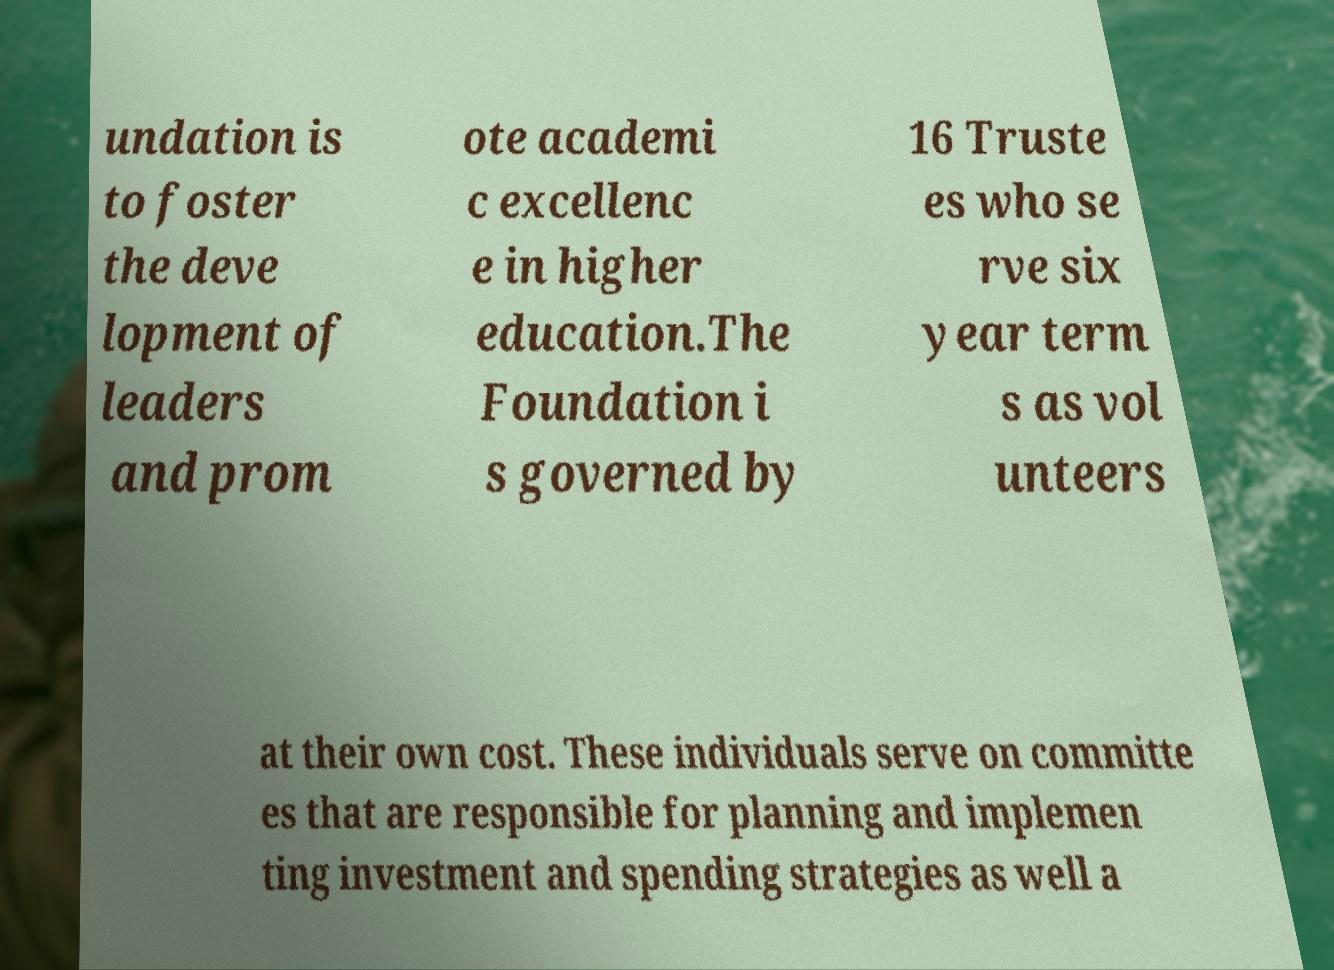Please identify and transcribe the text found in this image. undation is to foster the deve lopment of leaders and prom ote academi c excellenc e in higher education.The Foundation i s governed by 16 Truste es who se rve six year term s as vol unteers at their own cost. These individuals serve on committe es that are responsible for planning and implemen ting investment and spending strategies as well a 